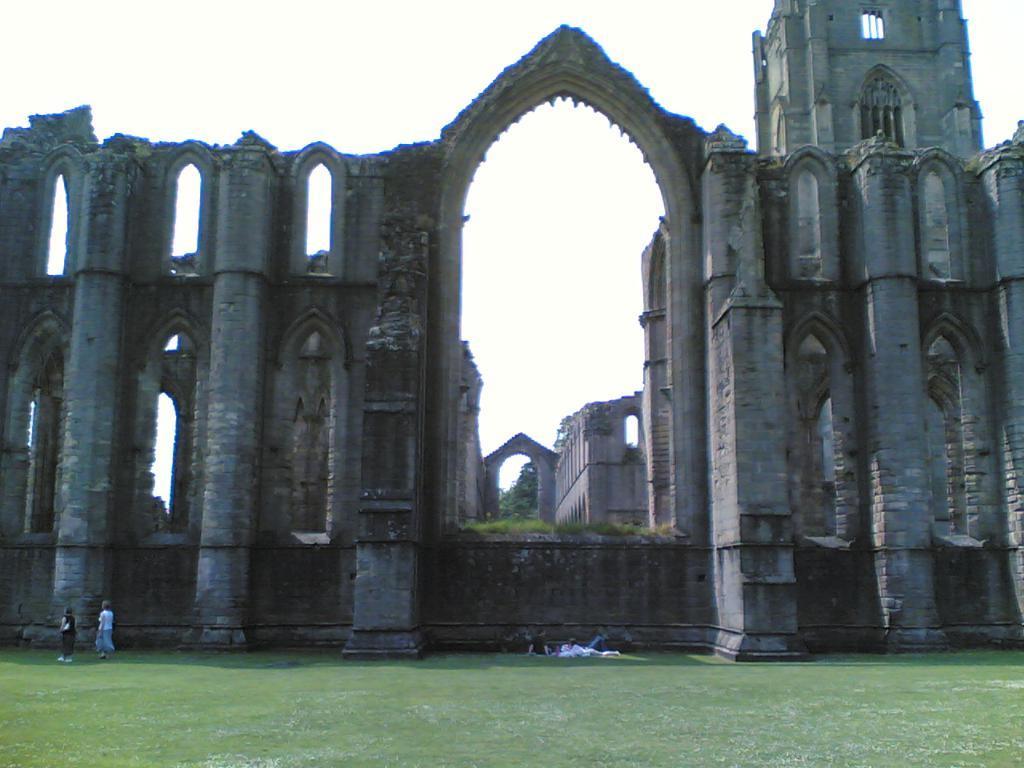Describe this image in one or two sentences. In this image there is a castle. In the foreground there is a ground. There are few people walking over here. On the ground few people are sitting. The sky is clear. 